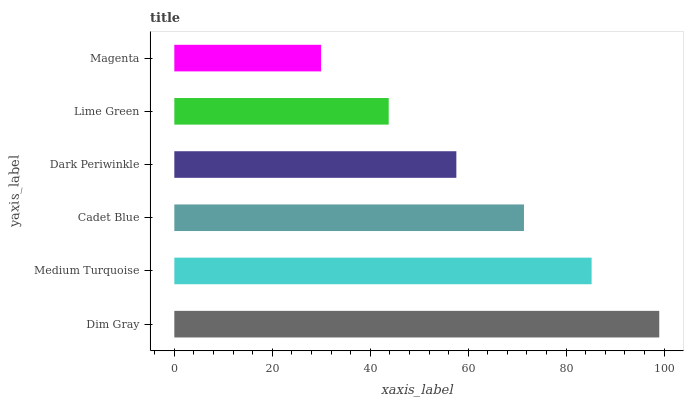Is Magenta the minimum?
Answer yes or no. Yes. Is Dim Gray the maximum?
Answer yes or no. Yes. Is Medium Turquoise the minimum?
Answer yes or no. No. Is Medium Turquoise the maximum?
Answer yes or no. No. Is Dim Gray greater than Medium Turquoise?
Answer yes or no. Yes. Is Medium Turquoise less than Dim Gray?
Answer yes or no. Yes. Is Medium Turquoise greater than Dim Gray?
Answer yes or no. No. Is Dim Gray less than Medium Turquoise?
Answer yes or no. No. Is Cadet Blue the high median?
Answer yes or no. Yes. Is Dark Periwinkle the low median?
Answer yes or no. Yes. Is Dark Periwinkle the high median?
Answer yes or no. No. Is Cadet Blue the low median?
Answer yes or no. No. 